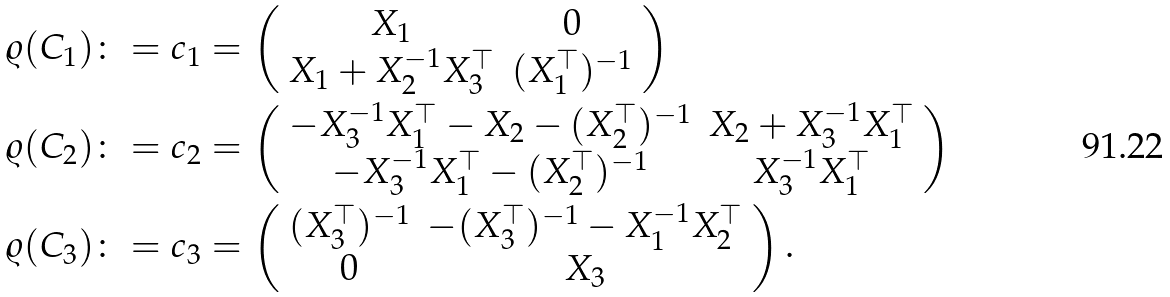<formula> <loc_0><loc_0><loc_500><loc_500>\varrho ( C _ { 1 } ) \colon = c _ { 1 } & = \left ( \begin{array} { c c } X _ { 1 } & 0 \\ X _ { 1 } + X _ { 2 } ^ { - 1 } X _ { 3 } ^ { \top } & ( X _ { 1 } ^ { \top } ) ^ { - 1 } \end{array} \right ) \\ \varrho ( C _ { 2 } ) \colon = c _ { 2 } & = \left ( \begin{array} { c c } - X _ { 3 } ^ { - 1 } X _ { 1 } ^ { \top } - X _ { 2 } - ( X _ { 2 } ^ { \top } ) ^ { - 1 } & X _ { 2 } + X _ { 3 } ^ { - 1 } X _ { 1 } ^ { \top } \\ - X _ { 3 } ^ { - 1 } X _ { 1 } ^ { \top } - ( X _ { 2 } ^ { \top } ) ^ { - 1 } & X _ { 3 } ^ { - 1 } X _ { 1 } ^ { \top } \end{array} \right ) \\ \varrho ( C _ { 3 } ) \colon = c _ { 3 } & = \left ( \begin{array} { c c } ( X _ { 3 } ^ { \top } ) ^ { - 1 } & - ( X _ { 3 } ^ { \top } ) ^ { - 1 } - X _ { 1 } ^ { - 1 } X _ { 2 } ^ { \top } \\ 0 & X _ { 3 } \end{array} \right ) .</formula> 